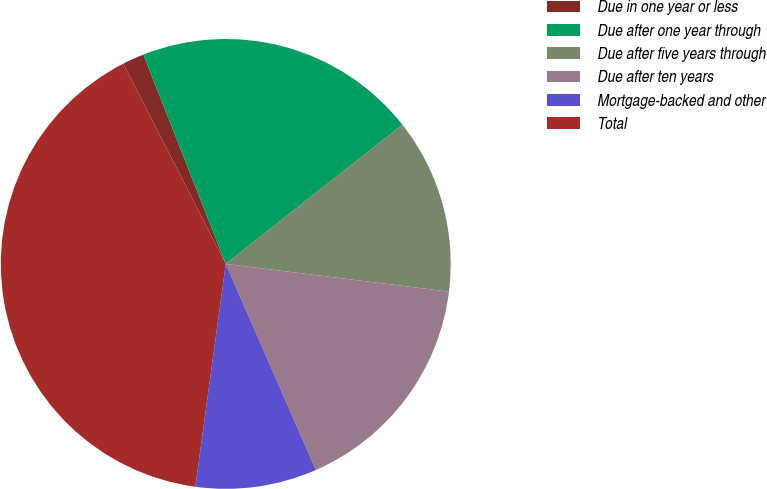<chart> <loc_0><loc_0><loc_500><loc_500><pie_chart><fcel>Due in one year or less<fcel>Due after one year through<fcel>Due after five years through<fcel>Due after ten years<fcel>Mortgage-backed and other<fcel>Total<nl><fcel>1.56%<fcel>20.34%<fcel>12.59%<fcel>16.47%<fcel>8.72%<fcel>40.31%<nl></chart> 